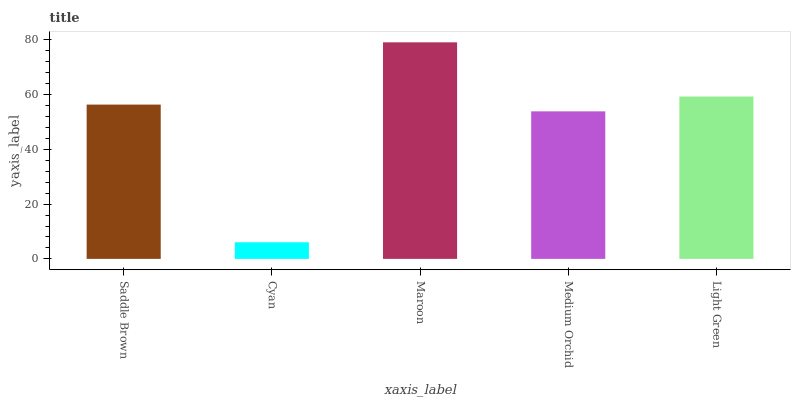Is Cyan the minimum?
Answer yes or no. Yes. Is Maroon the maximum?
Answer yes or no. Yes. Is Maroon the minimum?
Answer yes or no. No. Is Cyan the maximum?
Answer yes or no. No. Is Maroon greater than Cyan?
Answer yes or no. Yes. Is Cyan less than Maroon?
Answer yes or no. Yes. Is Cyan greater than Maroon?
Answer yes or no. No. Is Maroon less than Cyan?
Answer yes or no. No. Is Saddle Brown the high median?
Answer yes or no. Yes. Is Saddle Brown the low median?
Answer yes or no. Yes. Is Light Green the high median?
Answer yes or no. No. Is Cyan the low median?
Answer yes or no. No. 